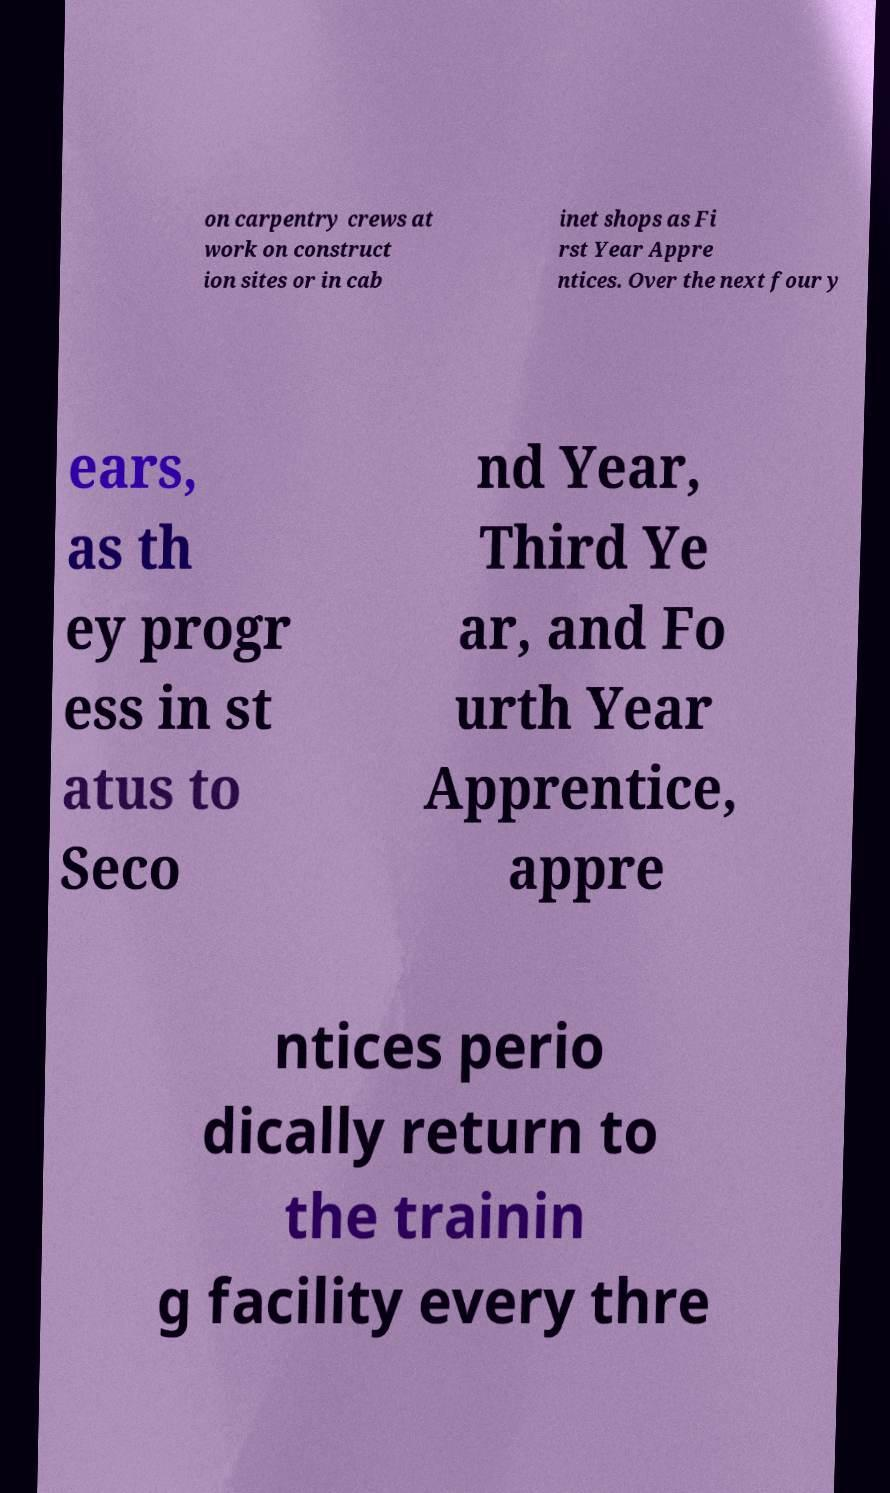Can you accurately transcribe the text from the provided image for me? on carpentry crews at work on construct ion sites or in cab inet shops as Fi rst Year Appre ntices. Over the next four y ears, as th ey progr ess in st atus to Seco nd Year, Third Ye ar, and Fo urth Year Apprentice, appre ntices perio dically return to the trainin g facility every thre 